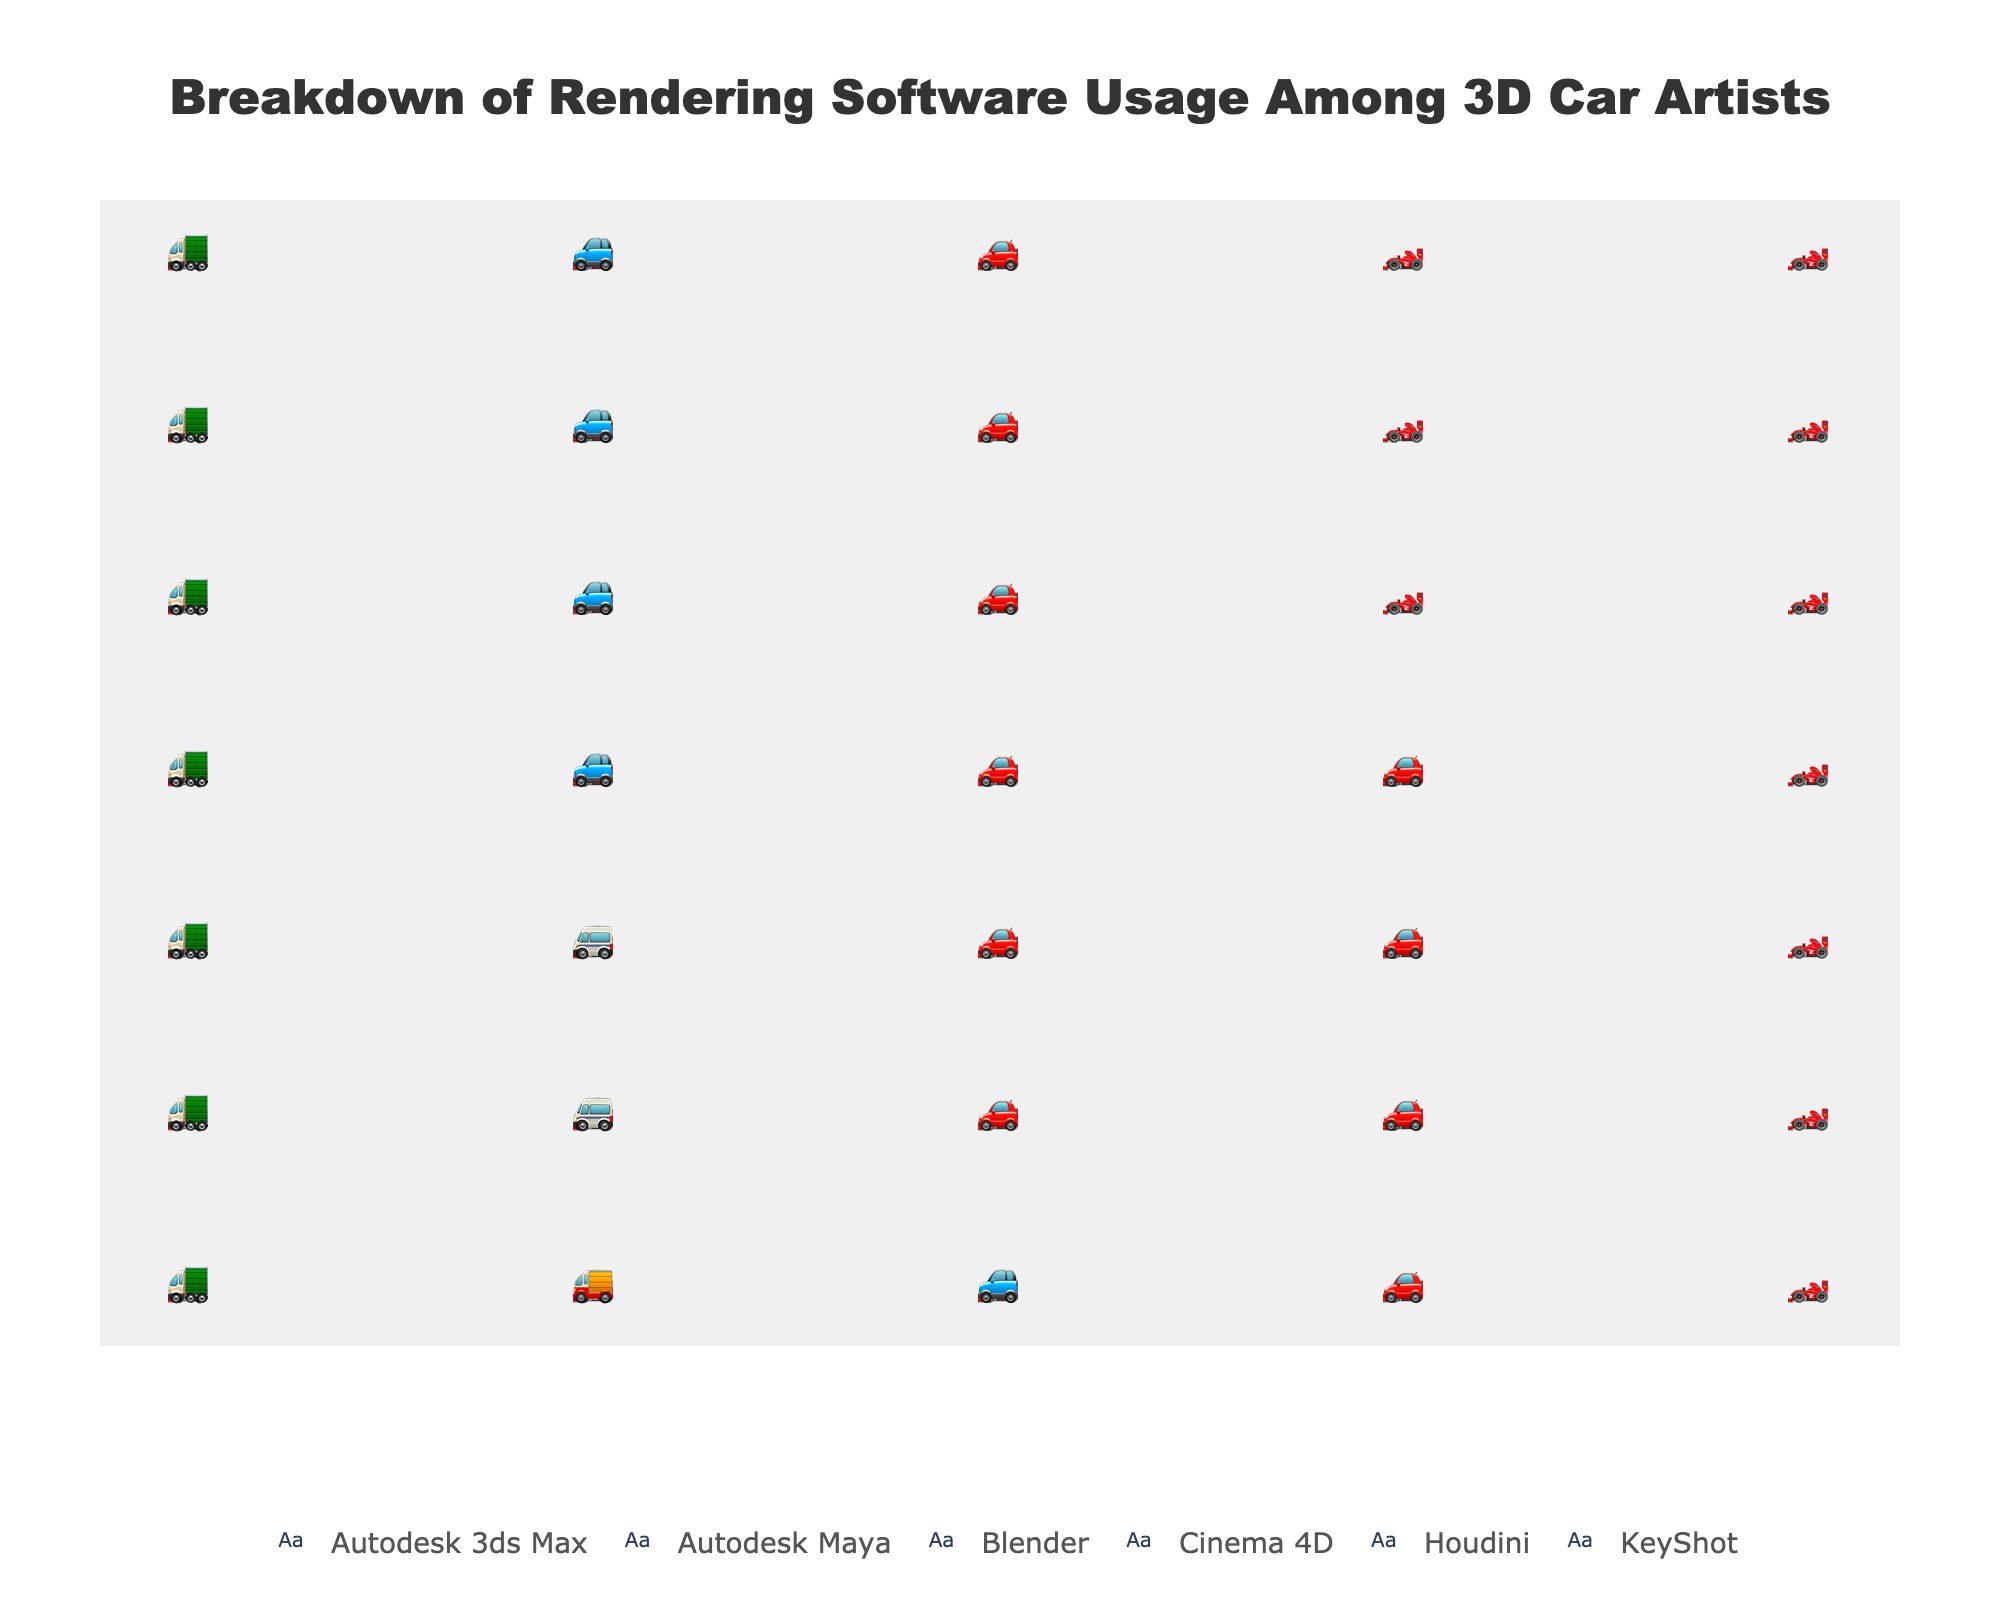what is the software used by the most car artists? The title indicates that the plot shows the breakdown of rendering software usage among 3D car artists. The software with the highest percentage has the most icons in the plot from a visual check. In this case, "Autodesk 3ds Max" has the most icons representing 35%.
Answer: Autodesk 3ds Max How many icons are representing Autodesk Maya? Each icon represents 1%, and Autodesk Maya has 25%, so there are 25 icons for Autodesk Maya in the plot.
Answer: 25 Which software has the second-highest usage percentage and what does it represent? By counting the number of icons for each software and comparing them, after Autodesk 3ds Max, which has the highest percentage, Autodesk Maya has the second highest with 25%.
Answer: Autodesk Maya, 25% What is the total percentage represented by Blender and Cinema 4D combined? Summing the percentages of Blender (15%) and Cinema 4D (10%) gives a total. 15% + 10% = 25%.
Answer: 25% How does the usage of KeyShot compare to that of Houdini? Both the ratios need to be visually compared by counting the respective icons or reading their percentages. Houdini has 8% usage, while KeyShot has 7% usage, so Houdini is used slightly more than KeyShot.
Answer: Houdini has 1% more usage than KeyShot How many more icons does Autodesk 3ds Max have compared to Blender? Autodesk 3ds Max has 35 icons, and Blender has 15 icons. The difference in icons is 35 - 15 = 20.
Answer: 20 more icons If the total number of icons represents 100%, what is the least used software and its percentage? By visually identifying the software with the fewest icons, which is KeyShot, and confirming it's 7% based on the percentage data.
Answer: KeyShot, 7% What is the combined percentage of usage for Houdini and KeyShot? Adding the percentages of Houdini (8%) and KeyShot (7%) gives a combined percentage. 8% + 7% = 15%.
Answer: 15% Which software has the closest number of icons to Cinema 4D and how many does it have? Cinema 4D has 10 icons. Comparing with other software, Houdini has 8 icons, which is the closest.
Answer: Houdini, 8 What is the visual representation symbol used for Blender? The plot shows different icons for each software. Blender is represented by the icon 🚙.
Answer: 🚙 